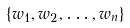<formula> <loc_0><loc_0><loc_500><loc_500>\{ w _ { 1 } , w _ { 2 } , \dots , w _ { n } \}</formula> 